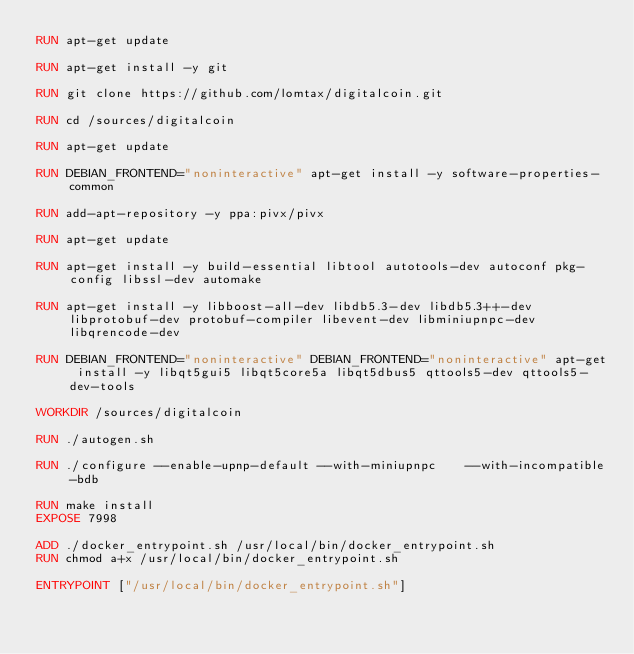Convert code to text. <code><loc_0><loc_0><loc_500><loc_500><_Dockerfile_>RUN apt-get update

RUN apt-get install -y git

RUN git clone https://github.com/lomtax/digitalcoin.git

RUN cd /sources/digitalcoin

RUN apt-get update 

RUN DEBIAN_FRONTEND="noninteractive" apt-get install -y software-properties-common

RUN add-apt-repository -y ppa:pivx/pivx

RUN apt-get update

RUN apt-get install -y build-essential libtool autotools-dev autoconf pkg-config libssl-dev automake

RUN apt-get install -y libboost-all-dev libdb5.3-dev libdb5.3++-dev libprotobuf-dev protobuf-compiler libevent-dev libminiupnpc-dev libqrencode-dev

RUN DEBIAN_FRONTEND="noninteractive" DEBIAN_FRONTEND="noninteractive" apt-get install -y libqt5gui5 libqt5core5a libqt5dbus5 qttools5-dev qttools5-dev-tools

WORKDIR /sources/digitalcoin

RUN ./autogen.sh

RUN ./configure --enable-upnp-default --with-miniupnpc    --with-incompatible-bdb

RUN make install
EXPOSE 7998

ADD ./docker_entrypoint.sh /usr/local/bin/docker_entrypoint.sh
RUN chmod a+x /usr/local/bin/docker_entrypoint.sh

ENTRYPOINT ["/usr/local/bin/docker_entrypoint.sh"]
</code> 